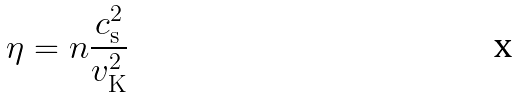Convert formula to latex. <formula><loc_0><loc_0><loc_500><loc_500>\eta = n \frac { c _ { \mathrm s } ^ { 2 } } { v _ { \mathrm K } ^ { 2 } }</formula> 